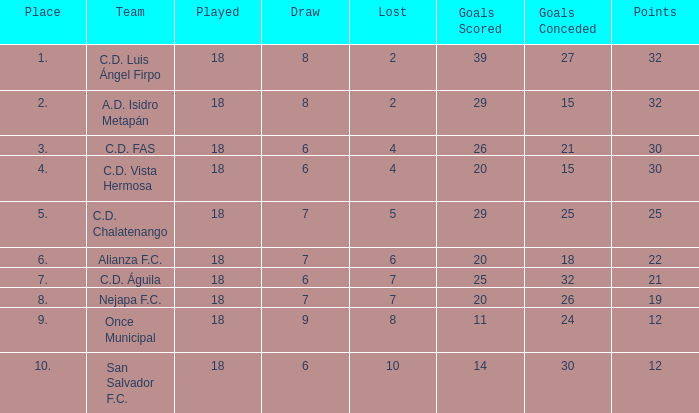What is the total of a draw with a loss less than 6, a position of 5, and goals scored under 29? None. 